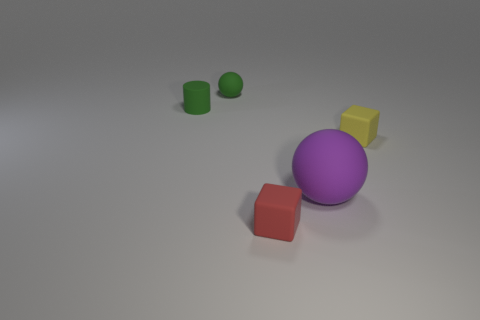How big is the cylinder?
Give a very brief answer. Small. What number of rubber objects are either large purple things or tiny yellow blocks?
Give a very brief answer. 2. Is the number of matte balls less than the number of tiny green balls?
Provide a succinct answer. No. What number of other things are the same material as the green ball?
Provide a short and direct response. 4. What is the size of the red object that is the same shape as the yellow matte thing?
Provide a succinct answer. Small. Do the small block right of the large thing and the tiny green thing on the right side of the tiny green cylinder have the same material?
Your response must be concise. Yes. Are there fewer red matte things that are left of the tiny yellow thing than small shiny spheres?
Offer a terse response. No. Are there any other things that are the same shape as the tiny red rubber object?
Provide a short and direct response. Yes. The other rubber object that is the same shape as the small yellow matte thing is what color?
Give a very brief answer. Red. There is a ball that is left of the purple sphere; is its size the same as the large purple thing?
Ensure brevity in your answer.  No. 